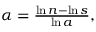Convert formula to latex. <formula><loc_0><loc_0><loc_500><loc_500>\begin{array} { r } { \alpha = \frac { \ln n - \ln s } { \ln a } , } \end{array}</formula> 